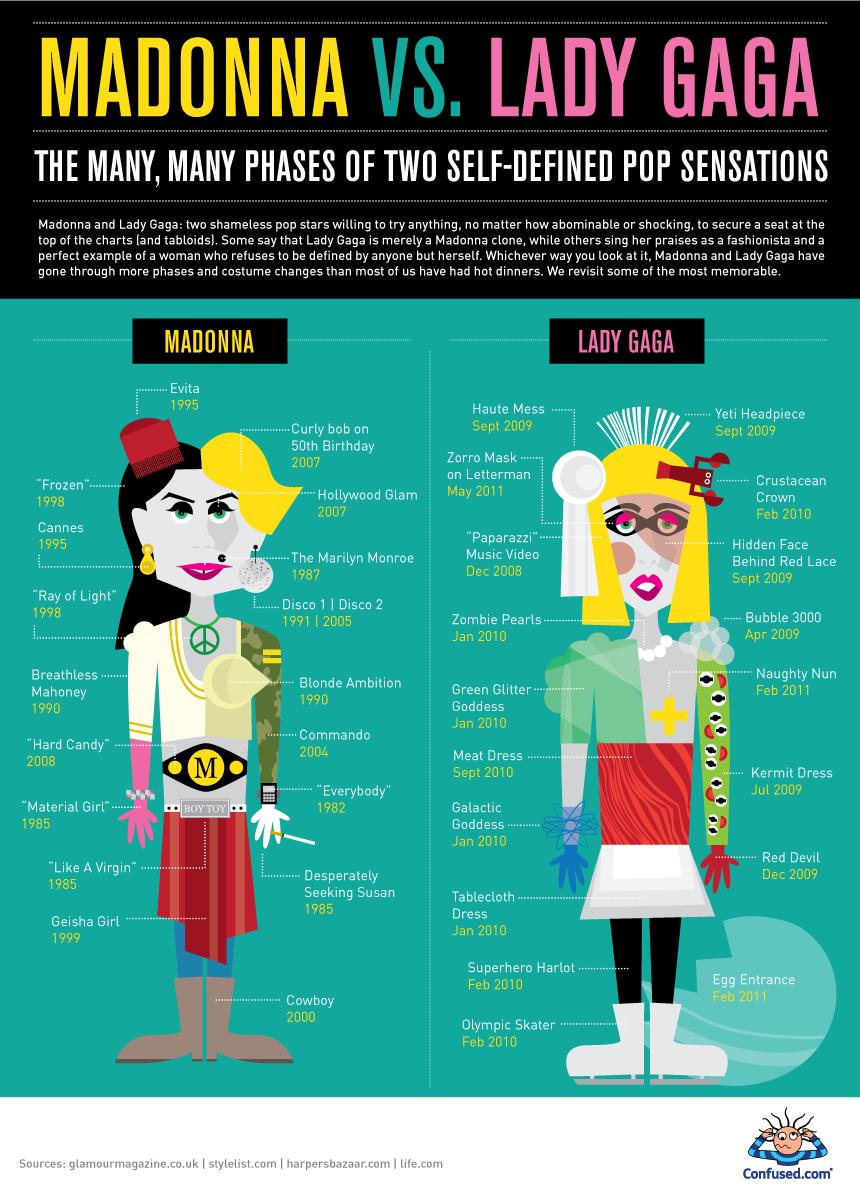List a handful of essential elements in this visual. Lady Gaga wore a Zorro mask on the Late Show with David Letterman in May 2011. Madonna's Disco 1 was released in the year 1991. The year associated with the release of "Zombie Pearls" by Lady Gaga is January 2010. The letter written on the belt of Madonna is 'M'. 